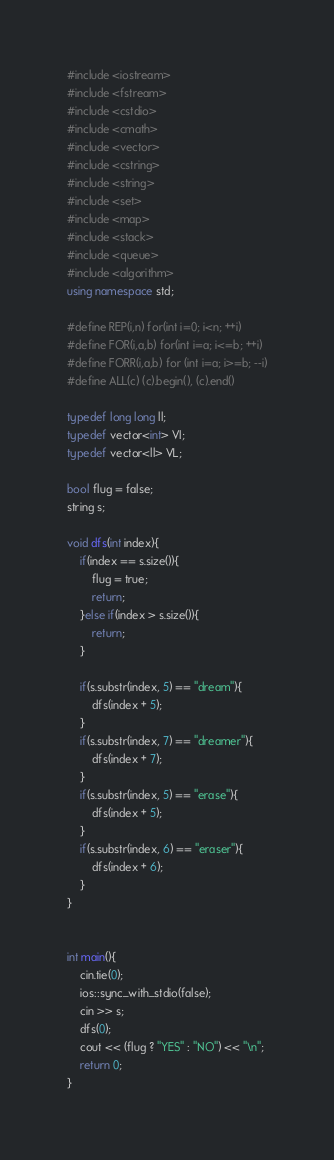Convert code to text. <code><loc_0><loc_0><loc_500><loc_500><_C++_>#include <iostream>
#include <fstream>
#include <cstdio>
#include <cmath>
#include <vector>
#include <cstring>
#include <string>
#include <set>
#include <map>
#include <stack>
#include <queue>
#include <algorithm>
using namespace std;

#define REP(i,n) for(int i=0; i<n; ++i)
#define FOR(i,a,b) for(int i=a; i<=b; ++i)
#define FORR(i,a,b) for (int i=a; i>=b; --i)
#define ALL(c) (c).begin(), (c).end()

typedef long long ll;
typedef vector<int> VI;
typedef vector<ll> VL;

bool flug = false;
string s;

void dfs(int index){
    if(index == s.size()){
        flug = true;
        return;
    }else if(index > s.size()){
        return;
    }

    if(s.substr(index, 5) == "dream"){
        dfs(index + 5);
    }
    if(s.substr(index, 7) == "dreamer"){
        dfs(index + 7);
    }
    if(s.substr(index, 5) == "erase"){
        dfs(index + 5);
    }
    if(s.substr(index, 6) == "eraser"){
        dfs(index + 6);
    }
}


int main(){
    cin.tie(0);
    ios::sync_with_stdio(false);
    cin >> s;
    dfs(0);
    cout << (flug ? "YES" : "NO") << "\n";
    return 0;
}
</code> 